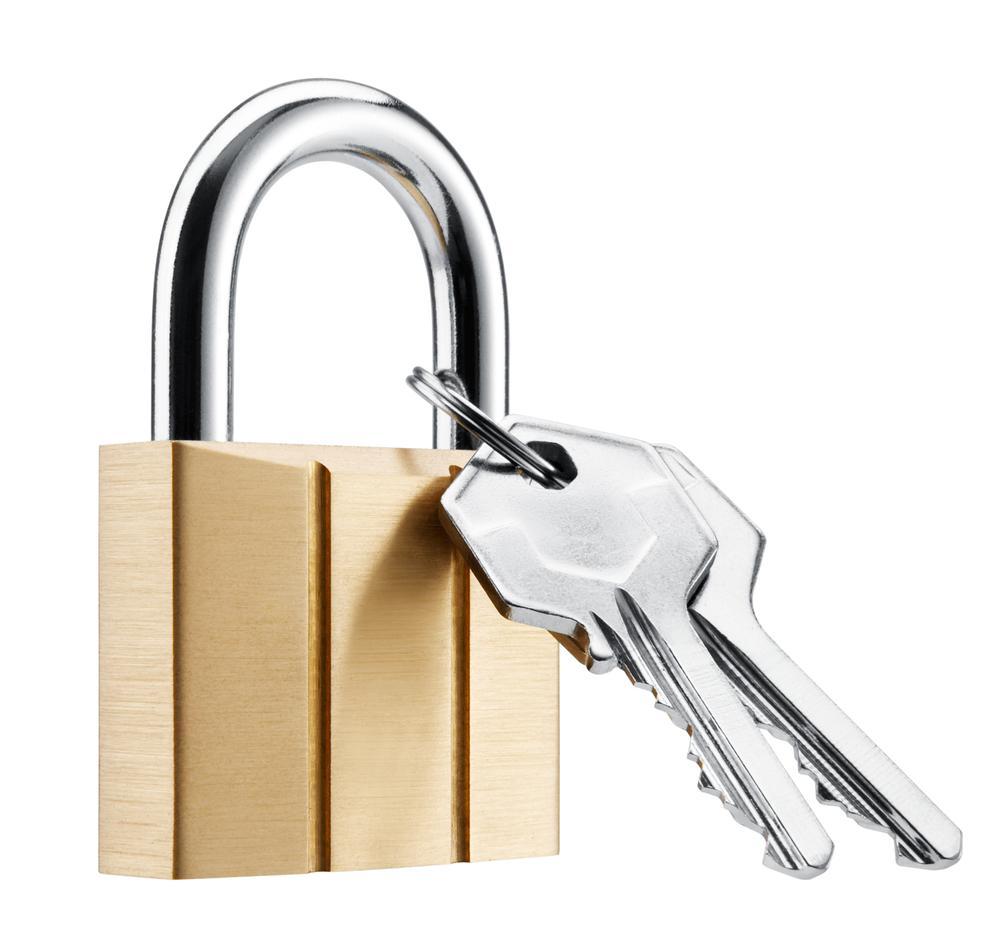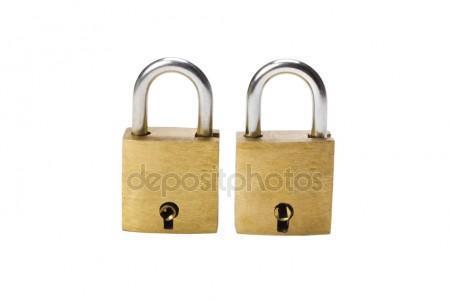The first image is the image on the left, the second image is the image on the right. Evaluate the accuracy of this statement regarding the images: "There's at least two keys in the right image.". Is it true? Answer yes or no. No. The first image is the image on the left, the second image is the image on the right. Evaluate the accuracy of this statement regarding the images: "An image shows a ring of keys next to, but not attached to, an upright lock.". Is it true? Answer yes or no. No. 